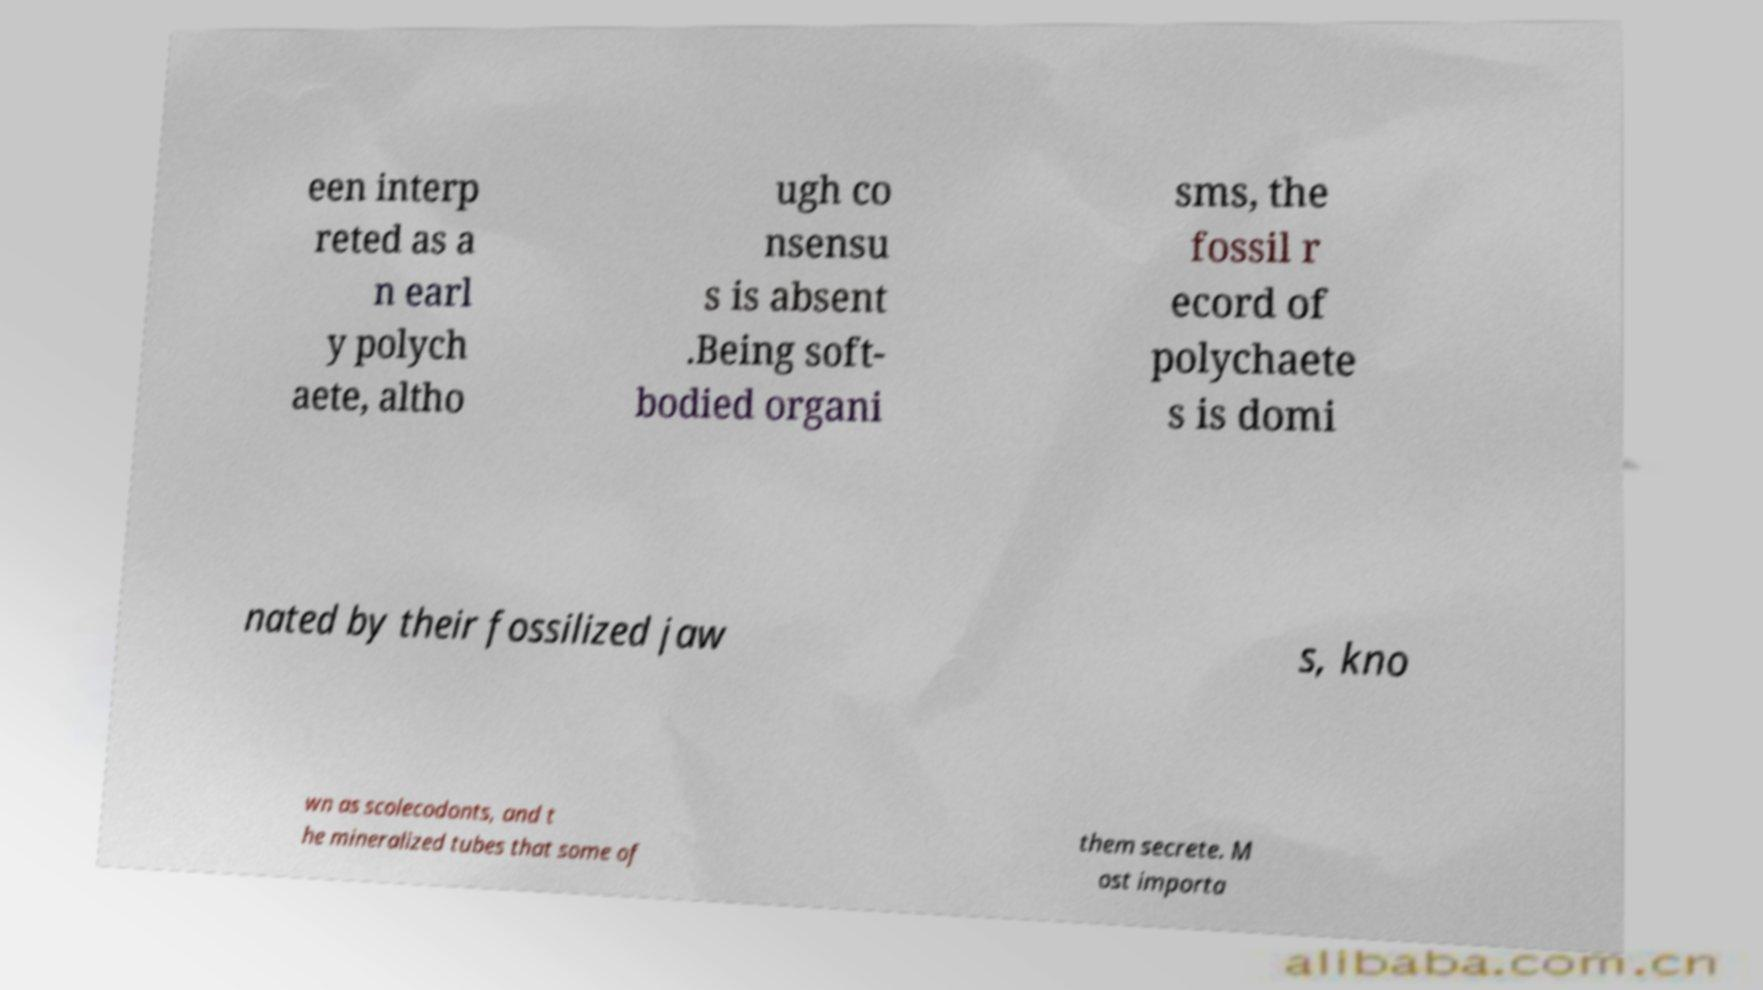What messages or text are displayed in this image? I need them in a readable, typed format. een interp reted as a n earl y polych aete, altho ugh co nsensu s is absent .Being soft- bodied organi sms, the fossil r ecord of polychaete s is domi nated by their fossilized jaw s, kno wn as scolecodonts, and t he mineralized tubes that some of them secrete. M ost importa 